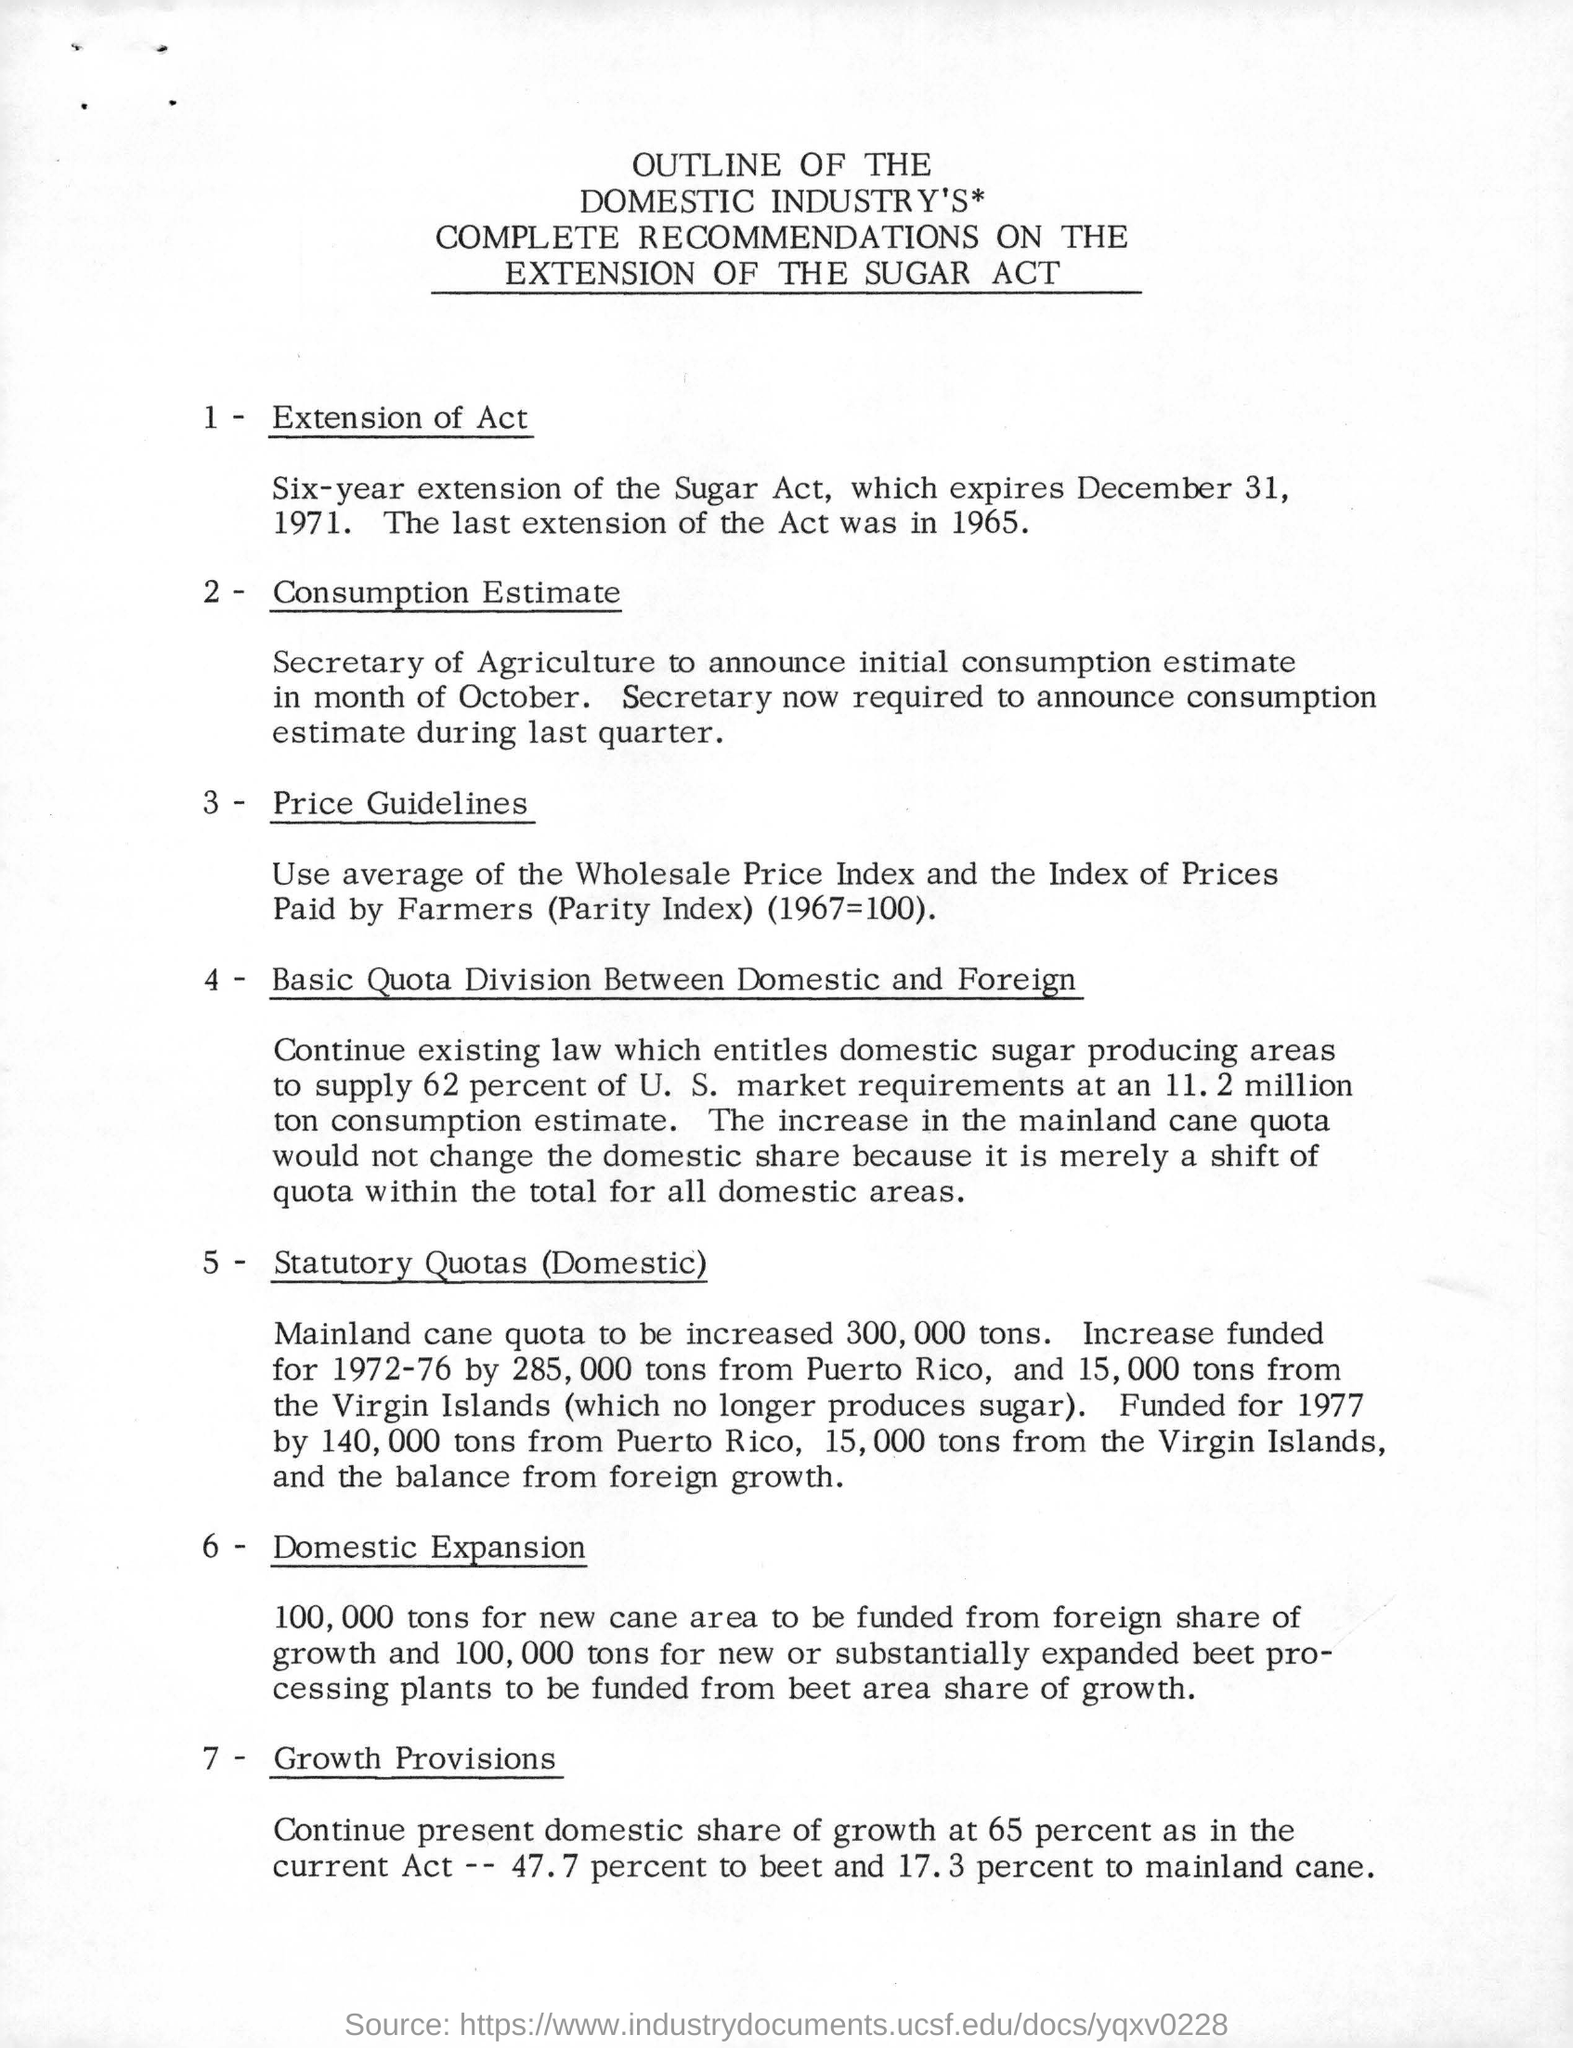Draw attention to some important aspects in this diagram. The Sugar Act was last extended in 1965. The Sugar Act will expire on December 31, 1971. 